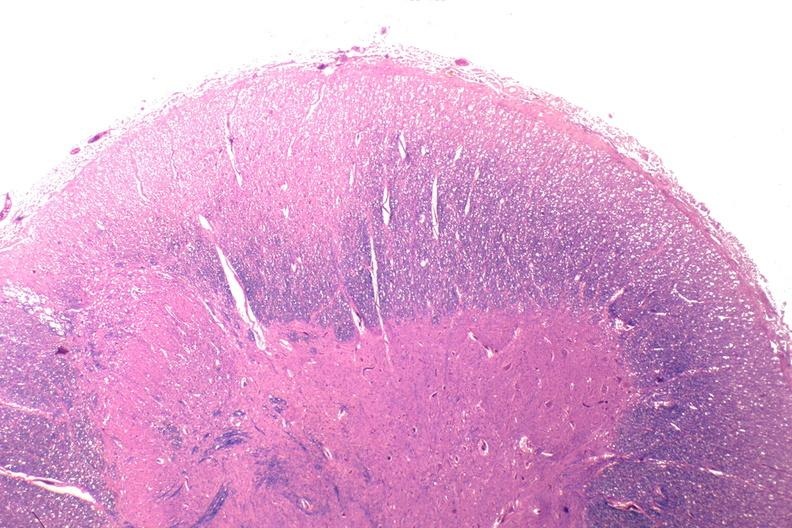does basal skull fracture show spinal cord injury due to vertebral column trauma, demyelination?
Answer the question using a single word or phrase. No 